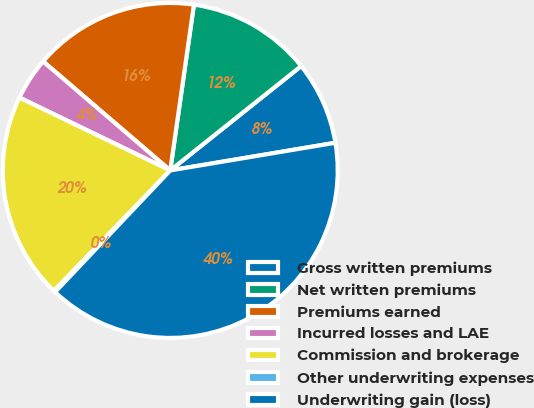Convert chart to OTSL. <chart><loc_0><loc_0><loc_500><loc_500><pie_chart><fcel>Gross written premiums<fcel>Net written premiums<fcel>Premiums earned<fcel>Incurred losses and LAE<fcel>Commission and brokerage<fcel>Other underwriting expenses<fcel>Underwriting gain (loss)<nl><fcel>8.07%<fcel>12.03%<fcel>15.98%<fcel>4.12%<fcel>19.94%<fcel>0.16%<fcel>39.71%<nl></chart> 